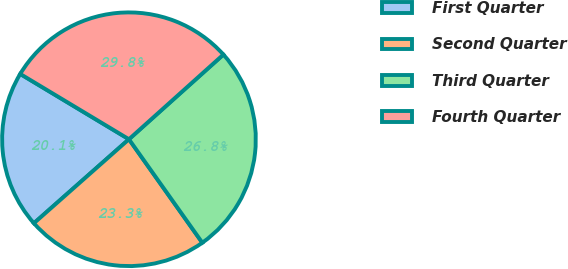Convert chart. <chart><loc_0><loc_0><loc_500><loc_500><pie_chart><fcel>First Quarter<fcel>Second Quarter<fcel>Third Quarter<fcel>Fourth Quarter<nl><fcel>20.13%<fcel>23.3%<fcel>26.82%<fcel>29.76%<nl></chart> 